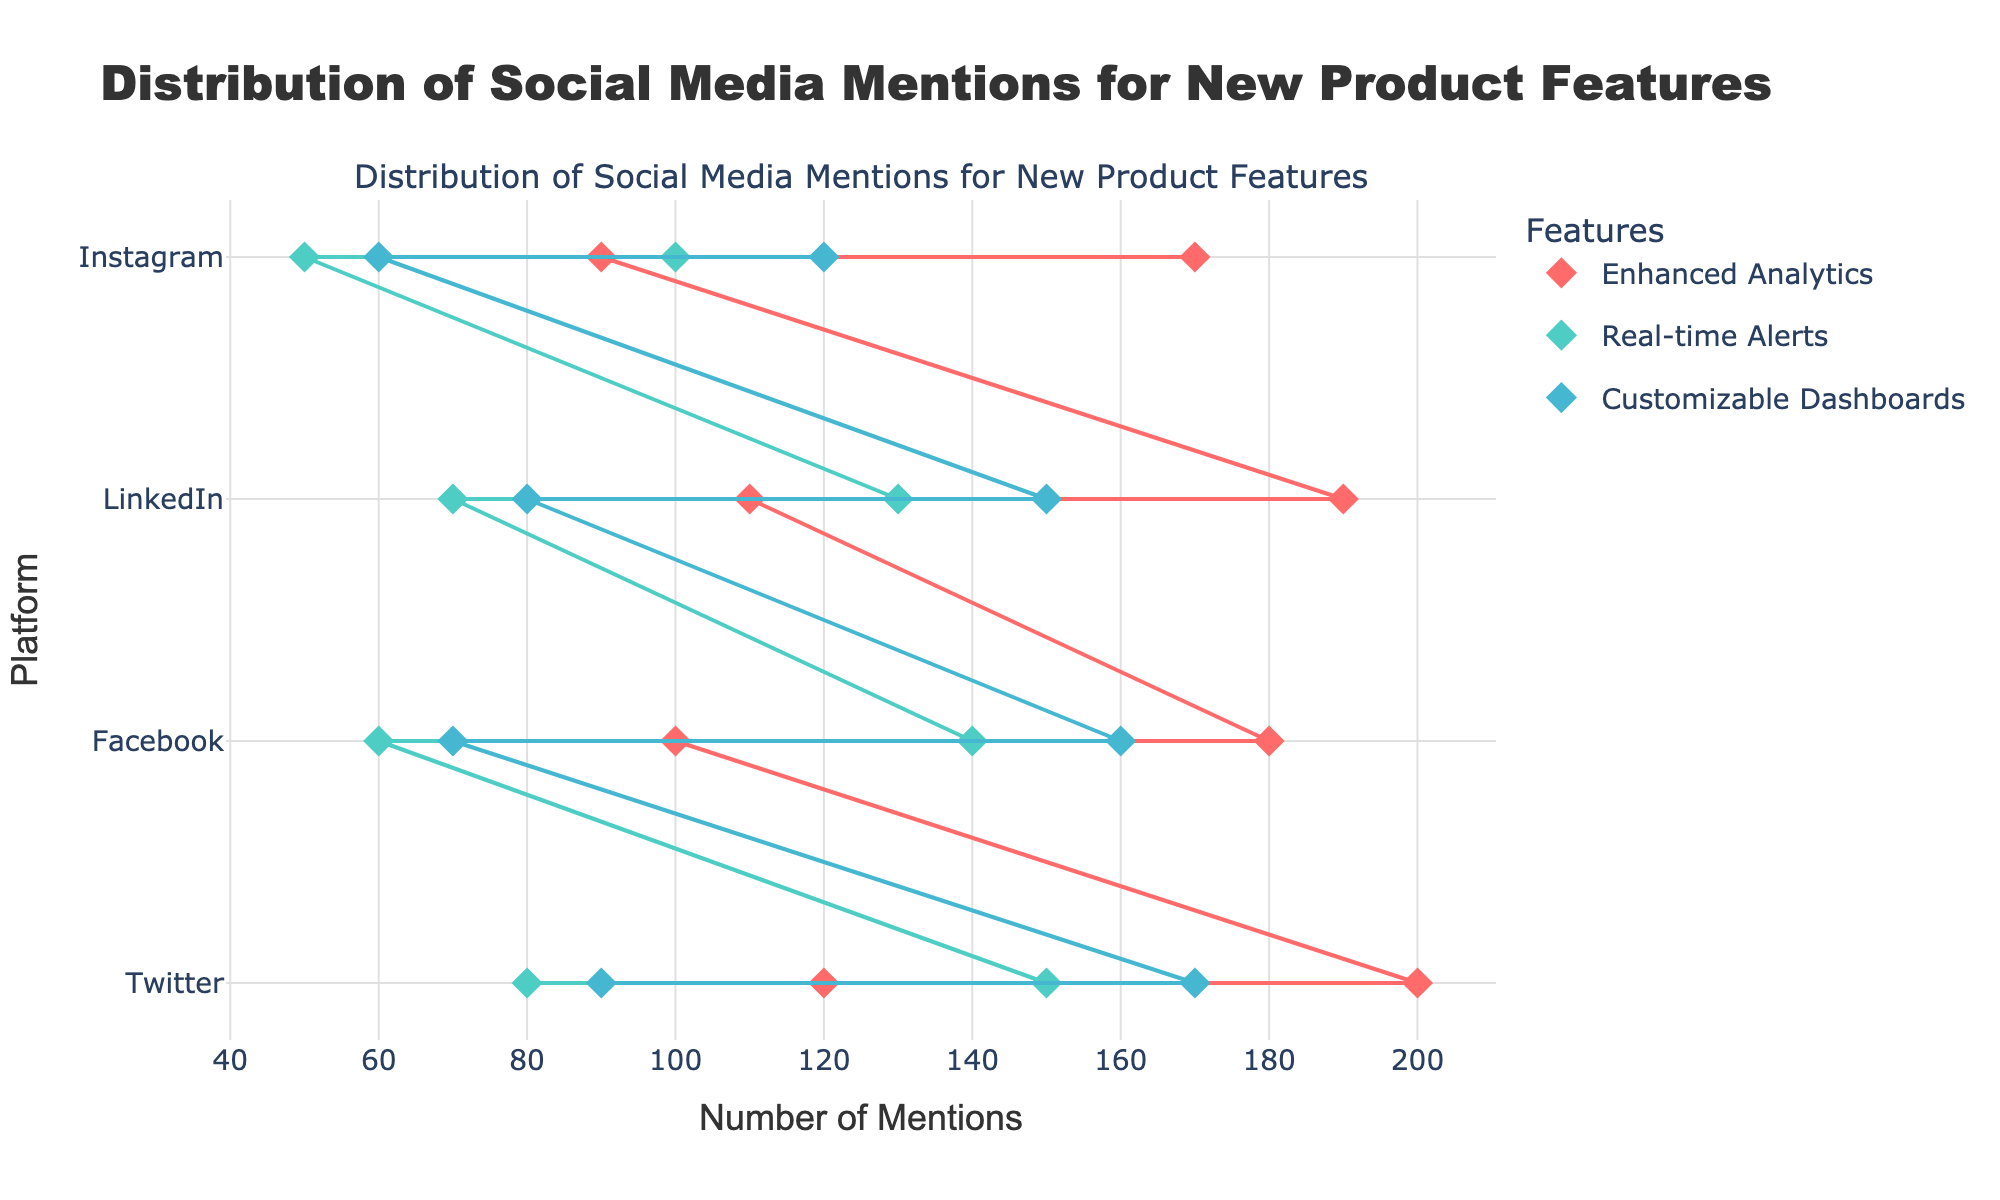What is the title of the plotted figure? The title is positioned at the top of the figure and typically describes what the figure is about.
Answer: Distribution of Social Media Mentions for New Product Features How many platforms are displayed in the figure? The platforms are listed along the y-axis of the plot. Counting the unique values shows the total number.
Answer: 4 Which platform has the lowest minimum mentions for the "Enhanced Analytics" feature? Look at the "Enhanced Analytics" markers and find the minimum value on the x-axis across the platforms.
Answer: Instagram What is the range of mentions for the "Customizable Dashboards" feature on LinkedIn? The range is the difference between the maximum and minimum mentions for the feature on LinkedIn as indicated by the endpoints of the line for this feature on the LinkedIn row.
Answer: 70 Which feature has the highest maximum mentions on Twitter? Compare the maximum mention values for all features on Twitter. The highest value will be the answer.
Answer: Enhanced Analytics What is the average of the maximum mentions for the "Real-time Alerts" feature across all platforms? Sum all the maximum mentions of the "Real-time Alerts" feature across platforms and divide by the number of platforms. (150 + 140 + 130 + 100) / 4 = 130
Answer: 130 Is the range of mentions for any feature wider on Facebook compared to its range on LinkedIn? Compare the ranges (Max - Min mentions) for each feature on Facebook and LinkedIn.
Answer: Yes How do the maximum mentions for "Customizable Dashboards" compare between Facebook and Instagram? Compare the x-axis position of the maximum mentions for "Customizable Dashboards" on Facebook and Instagram rows.
Answer: Facebook is higher Identify the platform and feature with the smallest range of mentions. Calculate the ranges for all features across all platforms. Identify the smallest one along with its platform and feature.
Answer: Instagram, Real-time Alerts Which feature on which platform has the second highest maximum mentions? Sort all maximum mention values in descending order and find the second highest one to identify its platform and feature.
Answer: LinkedIn, Enhanced Analytics 